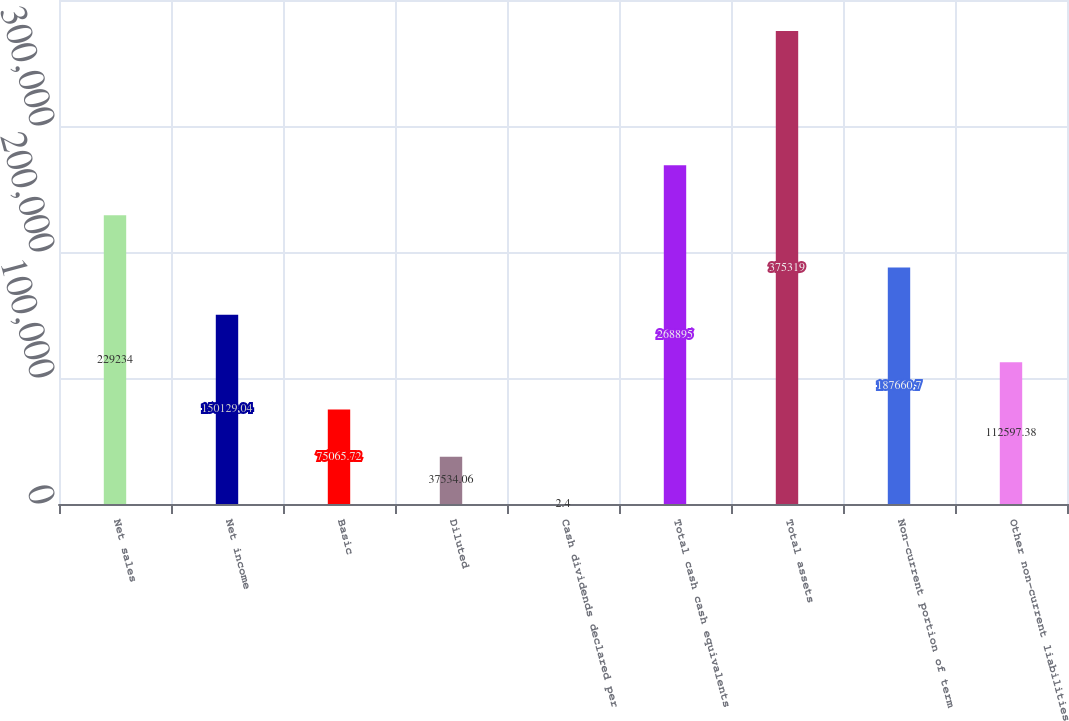Convert chart. <chart><loc_0><loc_0><loc_500><loc_500><bar_chart><fcel>Net sales<fcel>Net income<fcel>Basic<fcel>Diluted<fcel>Cash dividends declared per<fcel>Total cash cash equivalents<fcel>Total assets<fcel>Non-current portion of term<fcel>Other non-current liabilities<nl><fcel>229234<fcel>150129<fcel>75065.7<fcel>37534.1<fcel>2.4<fcel>268895<fcel>375319<fcel>187661<fcel>112597<nl></chart> 